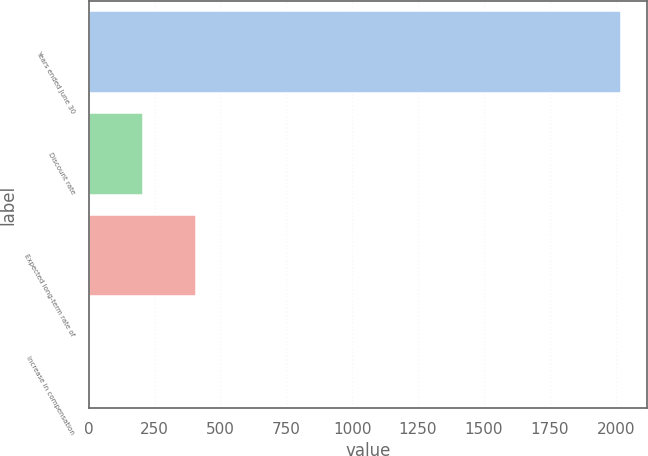Convert chart. <chart><loc_0><loc_0><loc_500><loc_500><bar_chart><fcel>Years ended June 30<fcel>Discount rate<fcel>Expected long-term rate of<fcel>Increase in compensation<nl><fcel>2019<fcel>205.5<fcel>407<fcel>4<nl></chart> 